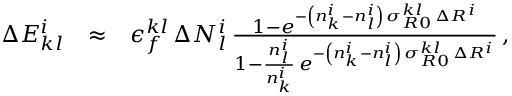Convert formula to latex. <formula><loc_0><loc_0><loc_500><loc_500>\begin{array} { r l r } { \Delta E _ { k l } ^ { i } } & { \approx } & { \epsilon _ { f } ^ { k l } \, \Delta N _ { l } ^ { i } \, \frac { 1 - e ^ { - \left ( n _ { k } ^ { i } - n _ { l } ^ { i } \right ) \, \sigma _ { R 0 } ^ { k l } \, \Delta R ^ { i } } } { 1 - \frac { n _ { l } ^ { i } } { n _ { k } ^ { i } } \, e ^ { - \left ( n _ { k } ^ { i } - n _ { l } ^ { i } \right ) \, \sigma _ { R 0 } ^ { k l } \, \Delta R ^ { i } } } \, , } \end{array}</formula> 